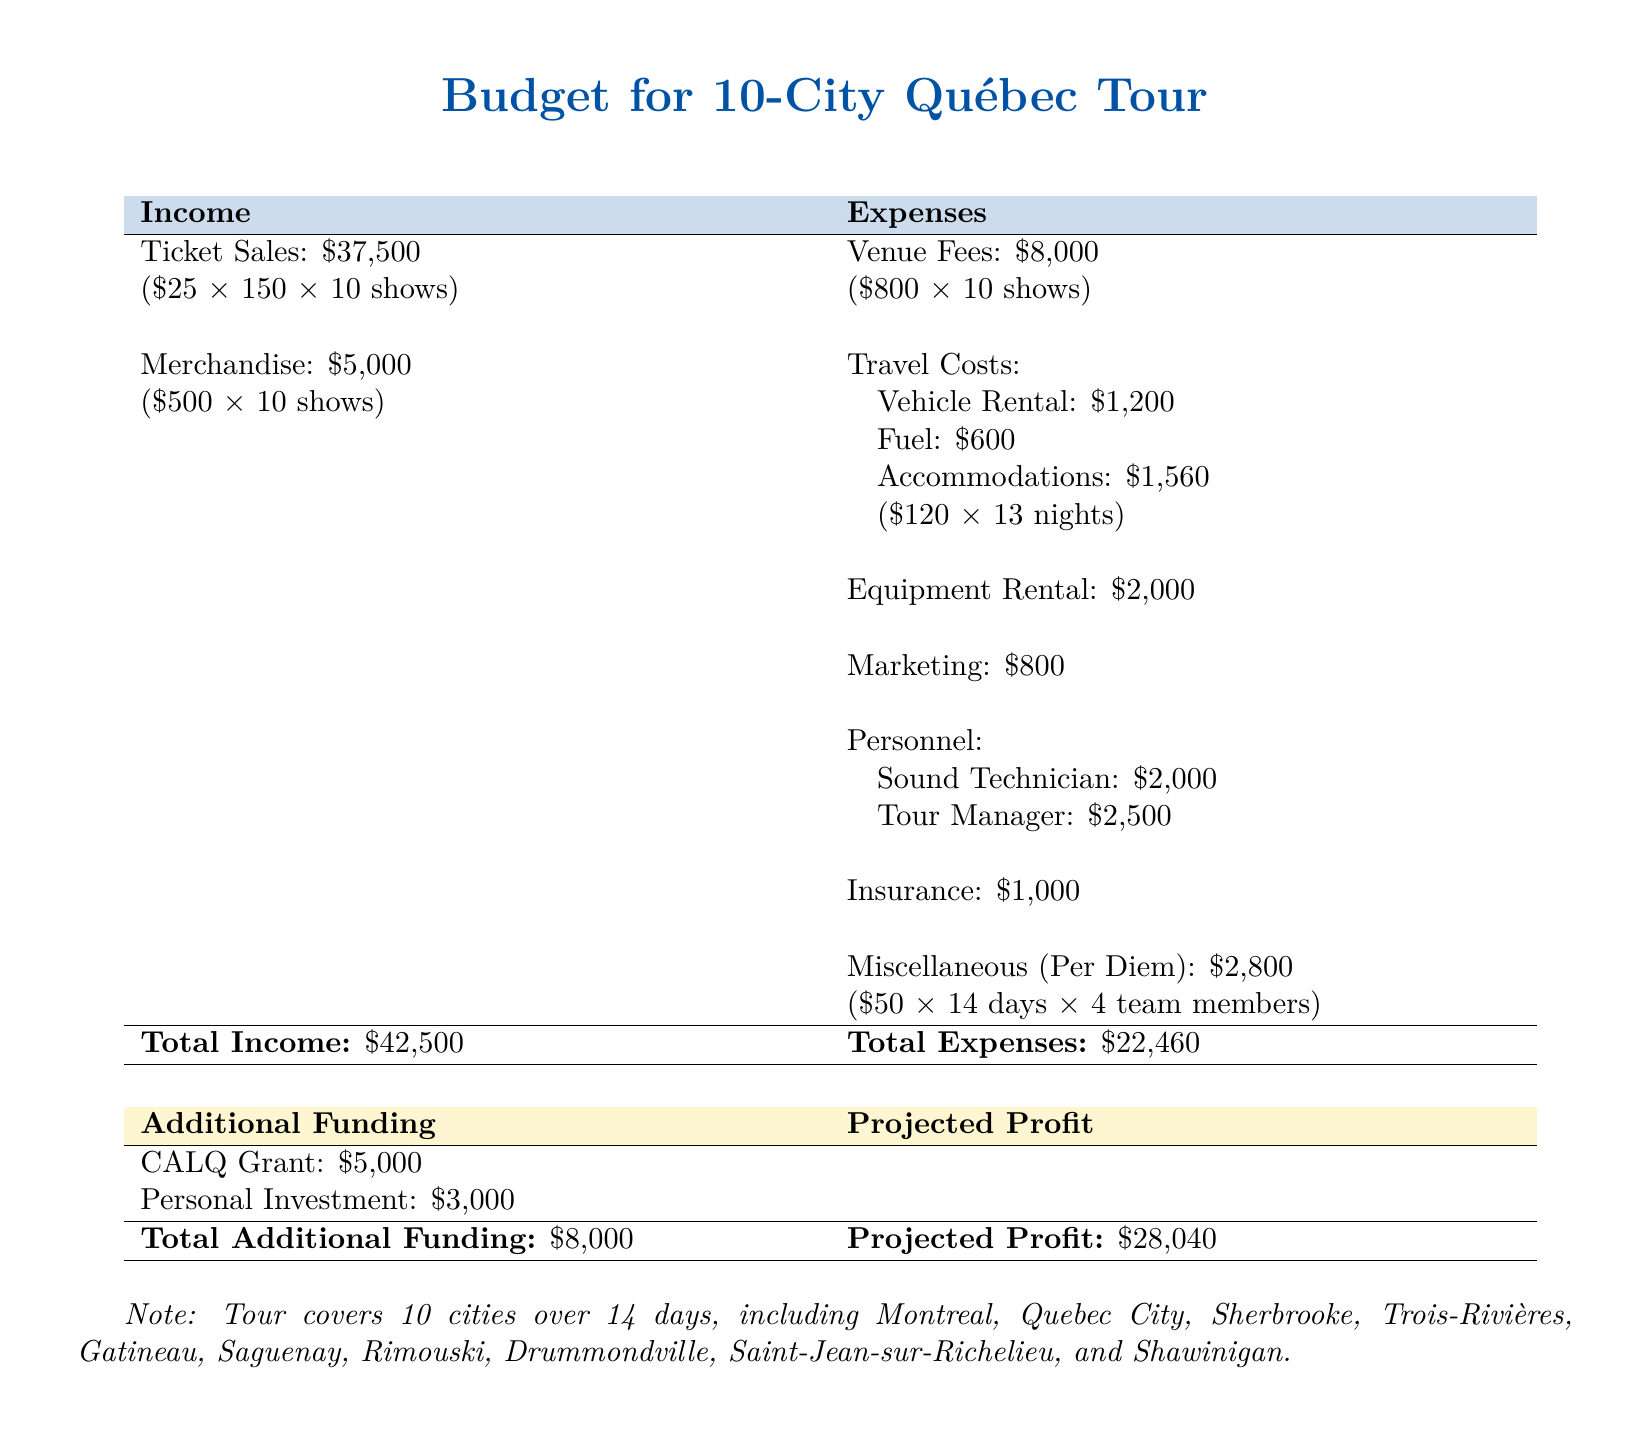What is the total income? The total income is the sum of ticket sales and merchandise in the document, which amounts to $37,500 + $5,000.
Answer: $42,500 What is the total expenses? The total expenses is the sum of all the expenses listed in the document, totaling $22,460.
Answer: $22,460 How many cities are covered in the tour? The note specifies that the tour covers 10 cities in total.
Answer: 10 cities What is the merchandise income? The document states that merchandise income is $5,000 for the tour.
Answer: $5,000 What is the venue fee per show? The venue fee for each show is mentioned as $800.
Answer: $800 What is the amount for travel costs? The travel costs detailed include vehicle rental, fuel, accommodations, and equipment rental, with a total of $1,200 + $600 + $1,560 + $2,000.
Answer: $5,360 What is the amount for personnel expenses? The personnel expenses include payments for both sound technician and tour manager, noted as $2,000 + $2,500.
Answer: $4,500 What is the total additional funding? The total additional funding is given as the sum of the CALQ grant and personal investment, which is $5,000 + $3,000.
Answer: $8,000 What is the projected profit? The projected profit is calculated as total income minus total expenses and is stated as $28,040.
Answer: $28,040 What is the total for miscellaneous expenses? The document lists miscellaneous expenses as the per diem for team members, which totals $2,800.
Answer: $2,800 